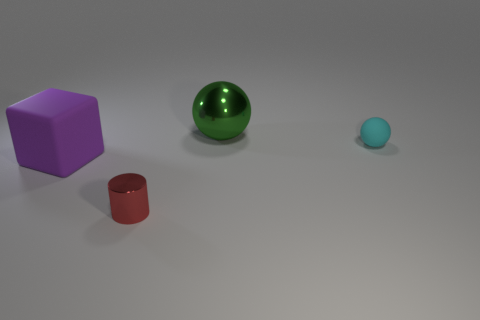There is a tiny cyan rubber object; what number of balls are to the left of it?
Make the answer very short. 1. Are there any red metallic spheres?
Provide a short and direct response. No. There is a metal thing that is behind the tiny object in front of the matte thing that is to the left of the cyan rubber ball; what is its color?
Offer a very short reply. Green. There is a matte thing that is to the right of the large block; is there a small matte object that is left of it?
Offer a terse response. No. How many red metal blocks have the same size as the matte ball?
Your answer should be very brief. 0. Is the size of the object on the left side of the metallic cylinder the same as the big green metallic object?
Make the answer very short. Yes. The small red object has what shape?
Offer a very short reply. Cylinder. Do the large object that is behind the rubber block and the red thing have the same material?
Make the answer very short. Yes. There is a shiny thing that is behind the small cyan matte ball; does it have the same shape as the object left of the red cylinder?
Provide a short and direct response. No. Are there any cylinders that have the same material as the big sphere?
Give a very brief answer. Yes. 